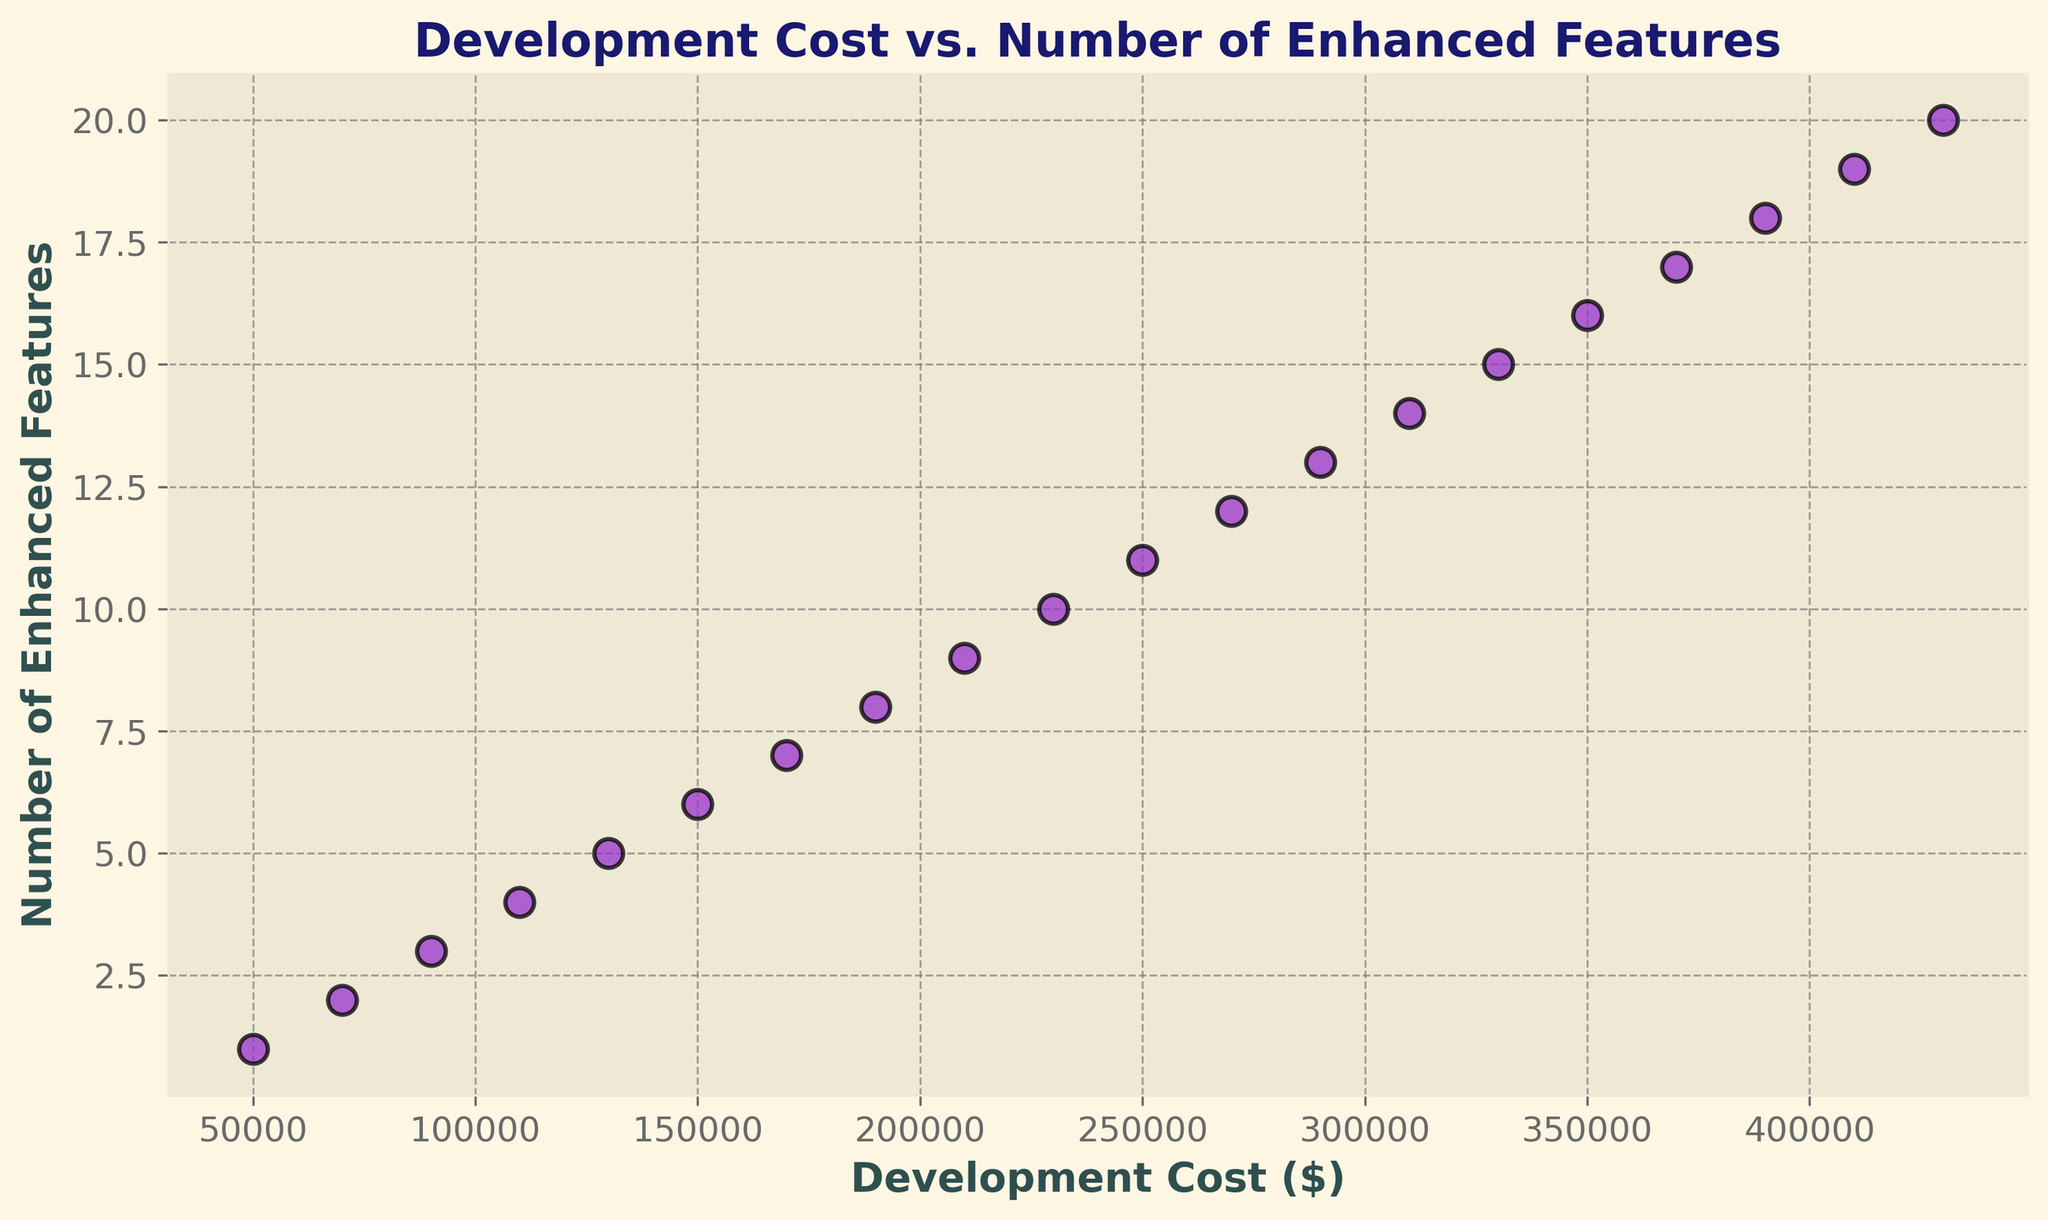What is the total Development Cost for implementing 10 enhanced features? The Development Cost for implementing 10 enhanced features is directly shown in the scatter plot. By looking at the plot, the point corresponding to 10 enhanced features shows a Development Cost of $230,000.
Answer: $230,000 Which data point has the highest Development Cost? The scatter plot shows an increasing trend, and the point with the highest Development Cost corresponds to the highest number of enhanced features, which is 20. The Development Cost for this point is $430,000.
Answer: $430,000 What is the average Development Cost for implementing 5, 10, and 15 enhanced features? First, identify the Development Costs for 5, 10, and 15 enhanced features from the plot. These are $130,000 (5), $230,000 (10), and $330,000 (15). Sum these values and divide by the number of data points: (130,000 + 230,000 + 330,000) / 3 = 690,000 / 3 = $230,000
Answer: $230,000 Is the Development Cost of implementing 18 enhanced features greater than implementing 6 and 12 combined? Extract the Development Costs for 18, 6, and 12 enhanced features from the plot. These are $390,000 (18), $150,000 (6), and $270,000 (12). The combined cost for 6 and 12 is $150,000 + $270,000 = $420,000. Since $390,000 is less than $420,000, the answer is no.
Answer: No What is the difference in Development Cost between implementing 8 and 17 enhanced features? Find the Development Costs for 8 and 17 enhanced features from the scatter plot, which are $190,000 (8) and $370,000 (17), respectively. The difference is $370,000 - $190,000 = $180,000.
Answer: $180,000 How many data points have a Development Cost greater than $300,000? Identify the data points that have a Development Cost greater than $300,000 by looking at the y-axis scale. The points correspond to 15, 16, 17, 18, 19, and 20 enhanced features. There are 6 data points in total.
Answer: 6 Which enhanced feature has a Development Cost just over $180,000? By inspecting the scatter plot, the data point just over $180,000 corresponds to 8 enhanced features, with a Development Cost of $190,000.
Answer: 8 By what amount does the Development Cost increase when moving from 12 to 14 enhanced features? Determine the costs for 12 and 14 enhanced features, which are $270,000 (12) and $310,000 (14). The increase in cost is $310,000 - $270,000 = $40,000.
Answer: $40,000 What is the visual relationship between the number of enhanced features and the Development Cost? Observing the scatter plot, there is a clear upward trend, showing a positive linear relationship between the number of enhanced features and the Development Cost. As the number of features increases, the Development Cost also increases.
Answer: Positive linear relationship 